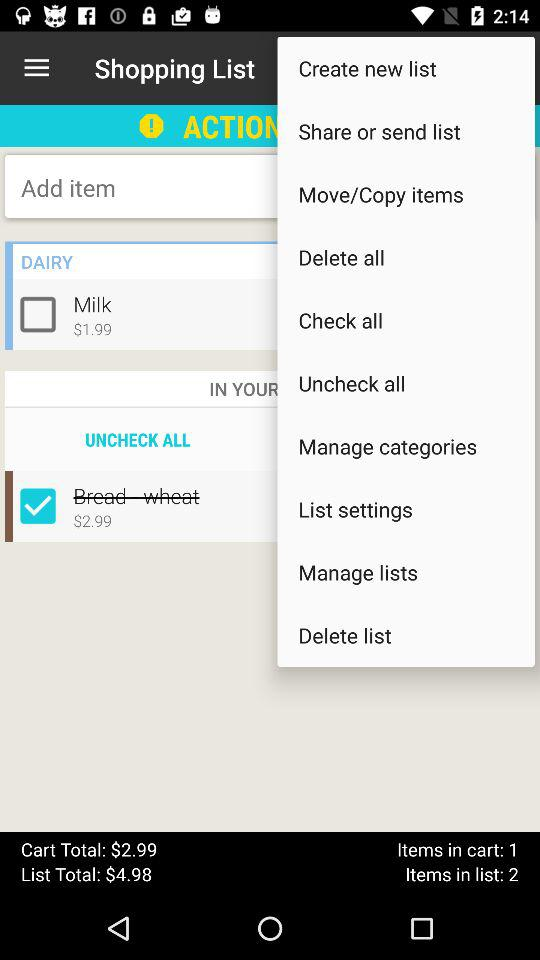What is the price for "Milk"? The price is $1.99. 